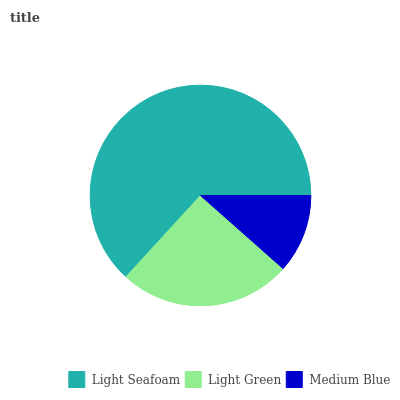Is Medium Blue the minimum?
Answer yes or no. Yes. Is Light Seafoam the maximum?
Answer yes or no. Yes. Is Light Green the minimum?
Answer yes or no. No. Is Light Green the maximum?
Answer yes or no. No. Is Light Seafoam greater than Light Green?
Answer yes or no. Yes. Is Light Green less than Light Seafoam?
Answer yes or no. Yes. Is Light Green greater than Light Seafoam?
Answer yes or no. No. Is Light Seafoam less than Light Green?
Answer yes or no. No. Is Light Green the high median?
Answer yes or no. Yes. Is Light Green the low median?
Answer yes or no. Yes. Is Light Seafoam the high median?
Answer yes or no. No. Is Medium Blue the low median?
Answer yes or no. No. 